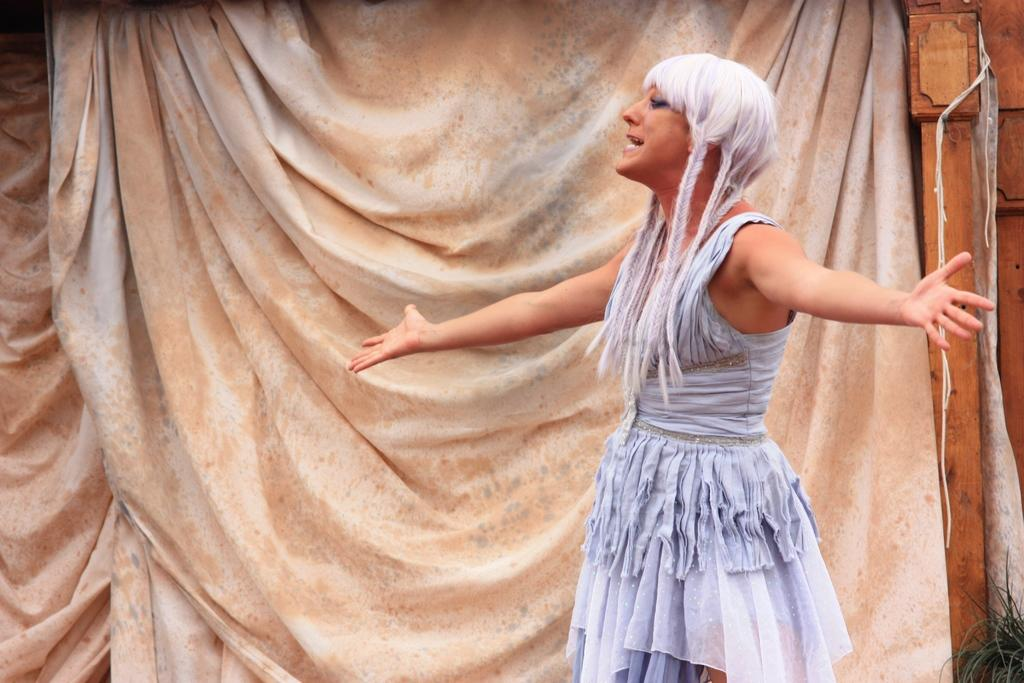What is the main subject in the image? There is a woman standing in the image. What can be seen in the background of the image? There is a plant, curtains, and a wooden object in the background of the image. What type of thought can be seen on the street in the image? There is no thought or street present in the image; it features a woman standing with a background containing a plant, curtains, and a wooden object. 